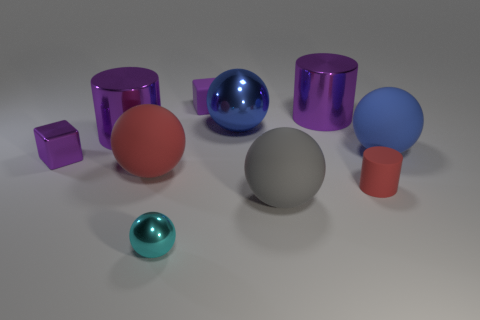Is the big shiny ball the same color as the rubber cylinder?
Provide a short and direct response. No. How many things are either tiny cubes that are left of the small purple matte block or purple cubes?
Your answer should be compact. 2. The red thing that is the same size as the cyan sphere is what shape?
Keep it short and to the point. Cylinder. There is a red matte thing to the right of the small cyan ball; is its size the same as the purple metallic cylinder that is on the left side of the large red matte sphere?
Your answer should be very brief. No. What is the color of the cube that is made of the same material as the large red sphere?
Your response must be concise. Purple. Is the material of the cylinder in front of the small purple metal thing the same as the cylinder that is on the left side of the big red rubber ball?
Make the answer very short. No. Is there a purple metallic thing of the same size as the gray thing?
Make the answer very short. Yes. What is the size of the cube on the right side of the tiny purple metal object that is behind the tiny cylinder?
Your answer should be very brief. Small. What number of small rubber objects are the same color as the rubber block?
Your answer should be compact. 0. What shape is the big object that is behind the blue ball left of the tiny red cylinder?
Provide a short and direct response. Cylinder. 